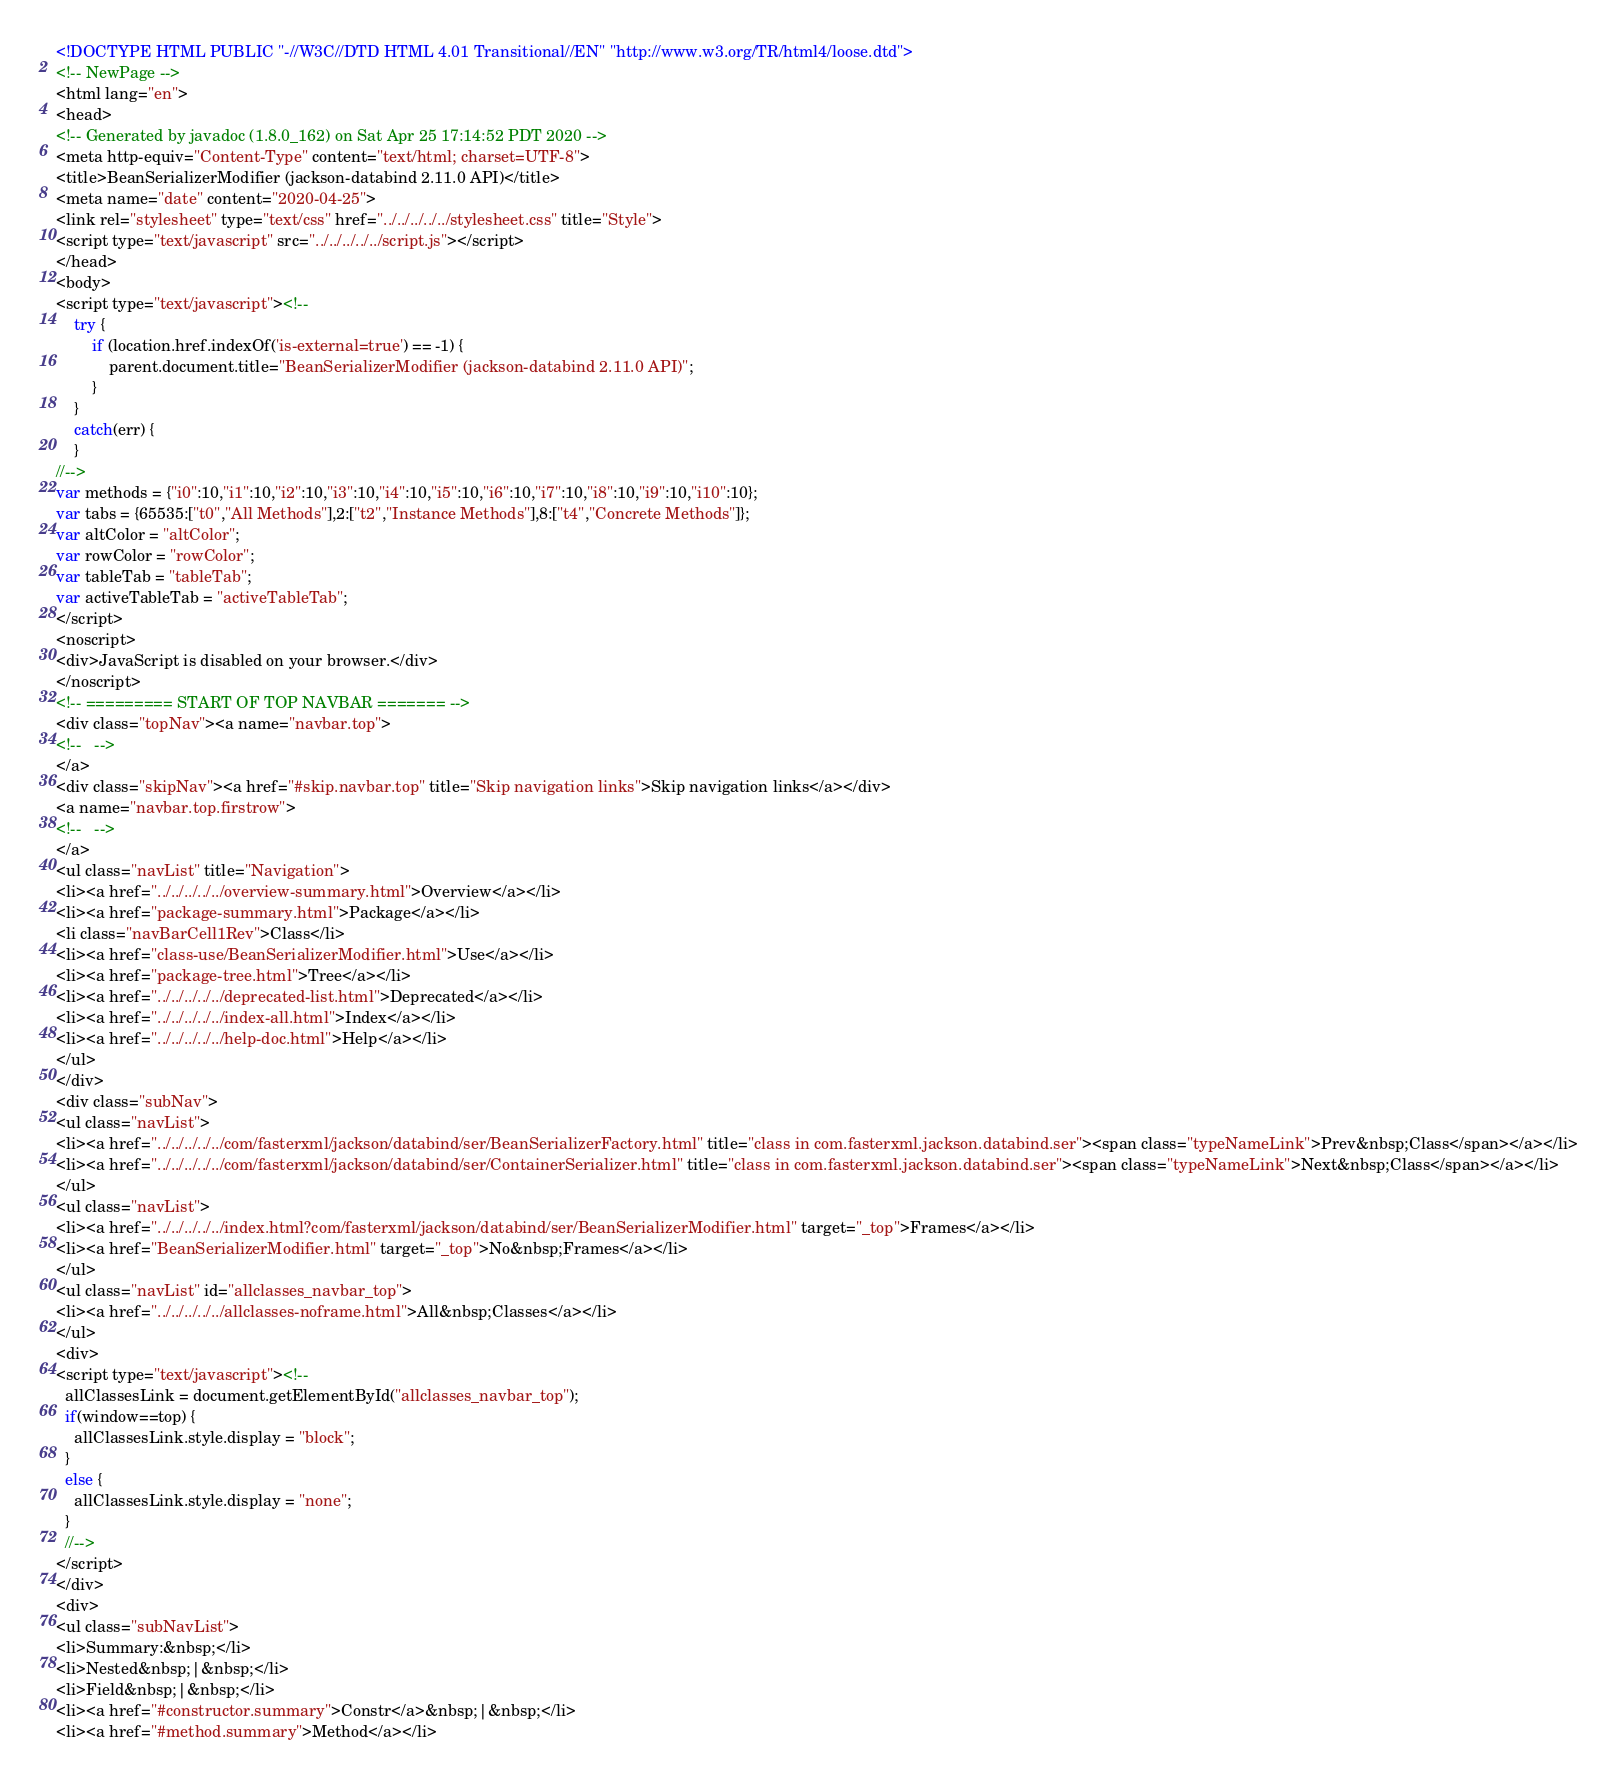<code> <loc_0><loc_0><loc_500><loc_500><_HTML_><!DOCTYPE HTML PUBLIC "-//W3C//DTD HTML 4.01 Transitional//EN" "http://www.w3.org/TR/html4/loose.dtd">
<!-- NewPage -->
<html lang="en">
<head>
<!-- Generated by javadoc (1.8.0_162) on Sat Apr 25 17:14:52 PDT 2020 -->
<meta http-equiv="Content-Type" content="text/html; charset=UTF-8">
<title>BeanSerializerModifier (jackson-databind 2.11.0 API)</title>
<meta name="date" content="2020-04-25">
<link rel="stylesheet" type="text/css" href="../../../../../stylesheet.css" title="Style">
<script type="text/javascript" src="../../../../../script.js"></script>
</head>
<body>
<script type="text/javascript"><!--
    try {
        if (location.href.indexOf('is-external=true') == -1) {
            parent.document.title="BeanSerializerModifier (jackson-databind 2.11.0 API)";
        }
    }
    catch(err) {
    }
//-->
var methods = {"i0":10,"i1":10,"i2":10,"i3":10,"i4":10,"i5":10,"i6":10,"i7":10,"i8":10,"i9":10,"i10":10};
var tabs = {65535:["t0","All Methods"],2:["t2","Instance Methods"],8:["t4","Concrete Methods"]};
var altColor = "altColor";
var rowColor = "rowColor";
var tableTab = "tableTab";
var activeTableTab = "activeTableTab";
</script>
<noscript>
<div>JavaScript is disabled on your browser.</div>
</noscript>
<!-- ========= START OF TOP NAVBAR ======= -->
<div class="topNav"><a name="navbar.top">
<!--   -->
</a>
<div class="skipNav"><a href="#skip.navbar.top" title="Skip navigation links">Skip navigation links</a></div>
<a name="navbar.top.firstrow">
<!--   -->
</a>
<ul class="navList" title="Navigation">
<li><a href="../../../../../overview-summary.html">Overview</a></li>
<li><a href="package-summary.html">Package</a></li>
<li class="navBarCell1Rev">Class</li>
<li><a href="class-use/BeanSerializerModifier.html">Use</a></li>
<li><a href="package-tree.html">Tree</a></li>
<li><a href="../../../../../deprecated-list.html">Deprecated</a></li>
<li><a href="../../../../../index-all.html">Index</a></li>
<li><a href="../../../../../help-doc.html">Help</a></li>
</ul>
</div>
<div class="subNav">
<ul class="navList">
<li><a href="../../../../../com/fasterxml/jackson/databind/ser/BeanSerializerFactory.html" title="class in com.fasterxml.jackson.databind.ser"><span class="typeNameLink">Prev&nbsp;Class</span></a></li>
<li><a href="../../../../../com/fasterxml/jackson/databind/ser/ContainerSerializer.html" title="class in com.fasterxml.jackson.databind.ser"><span class="typeNameLink">Next&nbsp;Class</span></a></li>
</ul>
<ul class="navList">
<li><a href="../../../../../index.html?com/fasterxml/jackson/databind/ser/BeanSerializerModifier.html" target="_top">Frames</a></li>
<li><a href="BeanSerializerModifier.html" target="_top">No&nbsp;Frames</a></li>
</ul>
<ul class="navList" id="allclasses_navbar_top">
<li><a href="../../../../../allclasses-noframe.html">All&nbsp;Classes</a></li>
</ul>
<div>
<script type="text/javascript"><!--
  allClassesLink = document.getElementById("allclasses_navbar_top");
  if(window==top) {
    allClassesLink.style.display = "block";
  }
  else {
    allClassesLink.style.display = "none";
  }
  //-->
</script>
</div>
<div>
<ul class="subNavList">
<li>Summary:&nbsp;</li>
<li>Nested&nbsp;|&nbsp;</li>
<li>Field&nbsp;|&nbsp;</li>
<li><a href="#constructor.summary">Constr</a>&nbsp;|&nbsp;</li>
<li><a href="#method.summary">Method</a></li></code> 